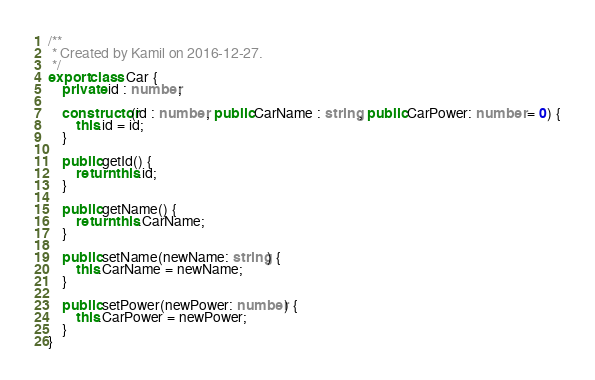<code> <loc_0><loc_0><loc_500><loc_500><_TypeScript_>/**
 * Created by Kamil on 2016-12-27.
 */
export class Car {
    private id : number;

    constructor(id : number, public CarName : string, public CarPower: number = 0) {
        this.id = id;
    }

    public getId() {
        return this.id;
    }

    public getName() {
        return this.CarName;
    }

    public setName(newName: string) {
        this.CarName = newName;
    }

    public setPower(newPower: number) {
        this.CarPower = newPower;
    }
}

</code> 